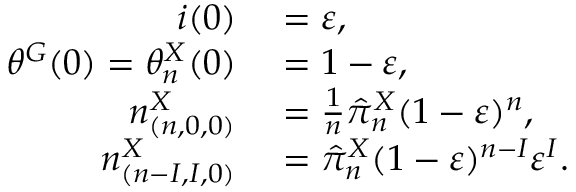Convert formula to latex. <formula><loc_0><loc_0><loc_500><loc_500>\begin{array} { r l } { i ( 0 ) } & = \varepsilon , } \\ { \theta ^ { G } ( 0 ) = \theta _ { n } ^ { X } ( 0 ) } & = 1 - \varepsilon , } \\ { n _ { ( n , 0 , 0 ) } ^ { X } } & = \frac { 1 } { n } \hat { \pi } _ { n } ^ { X } ( 1 - \varepsilon ) ^ { n } , } \\ { n _ { ( n - I , I , 0 ) } ^ { X } } & = \hat { \pi } _ { n } ^ { X } ( 1 - \varepsilon ) ^ { n - I } \varepsilon ^ { I } . } \end{array}</formula> 